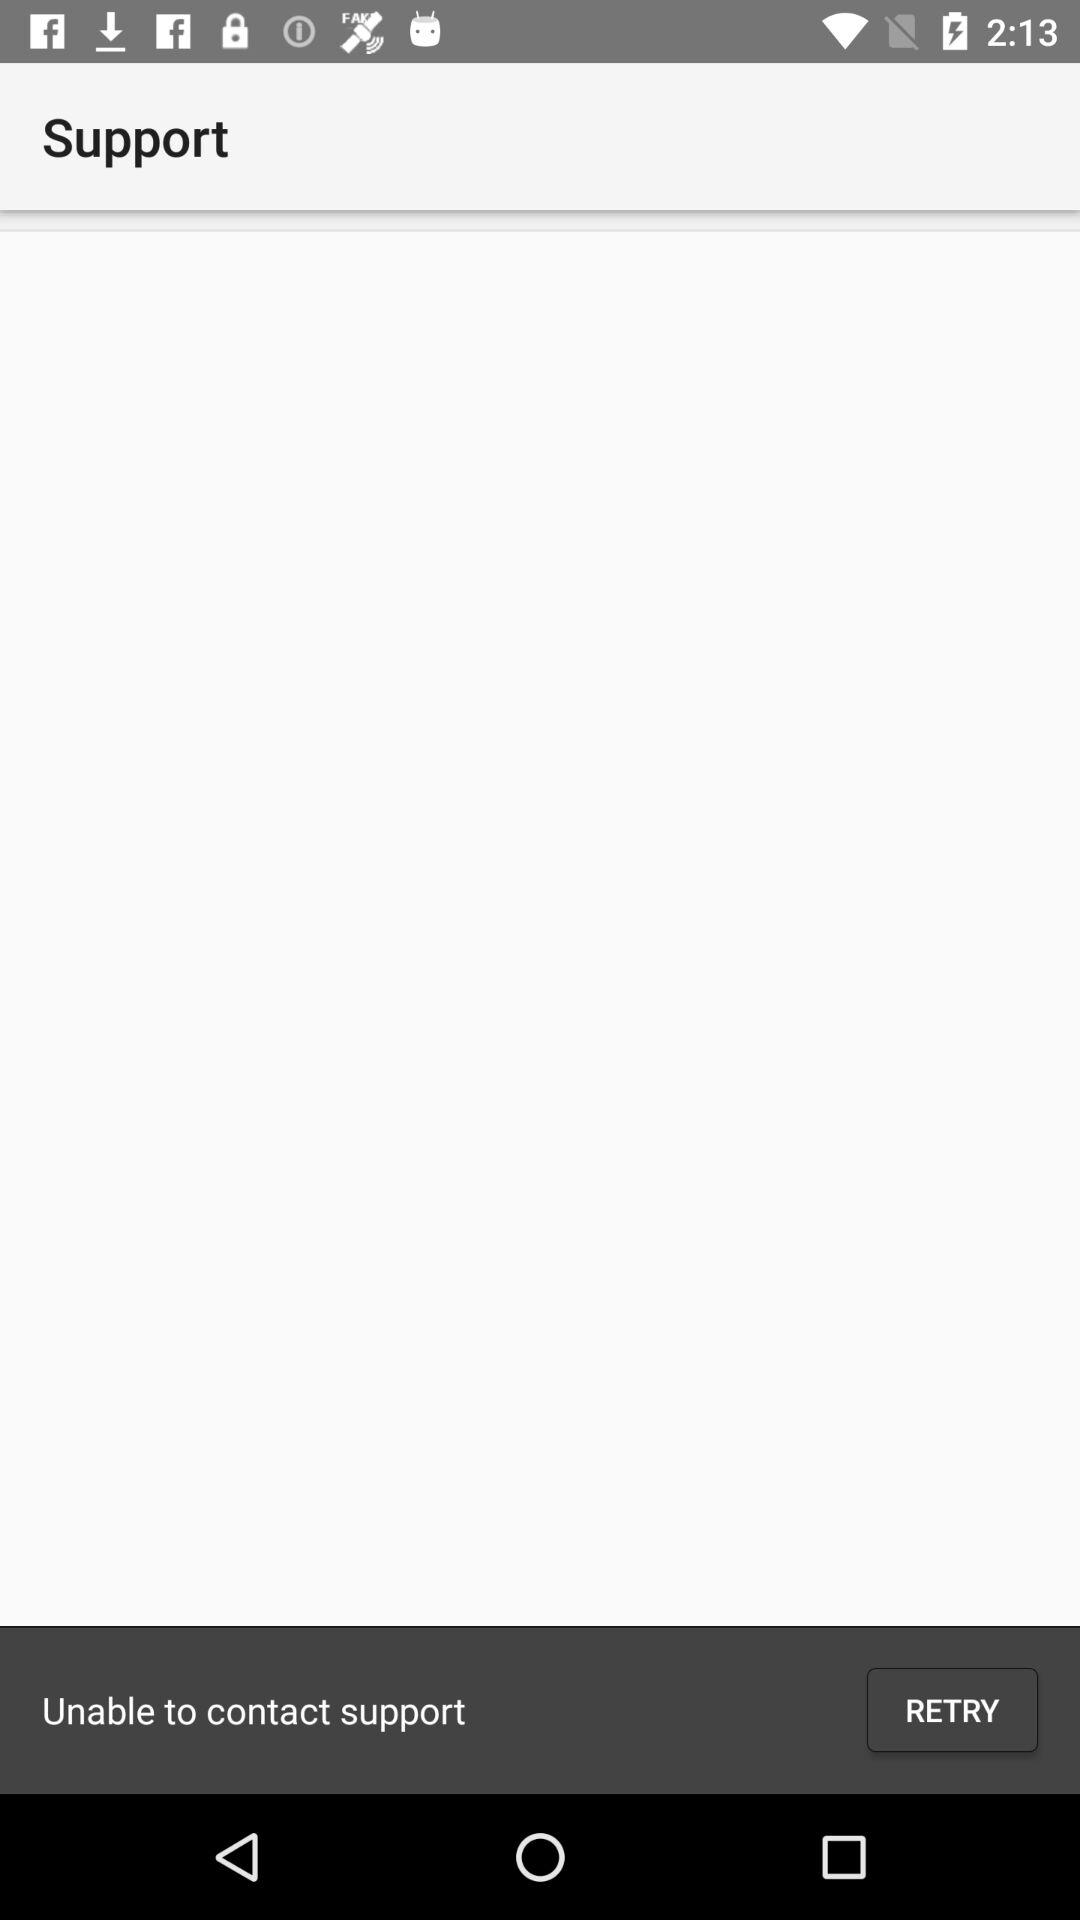How many numbers are on the screen?
Answer the question using a single word or phrase. 3 